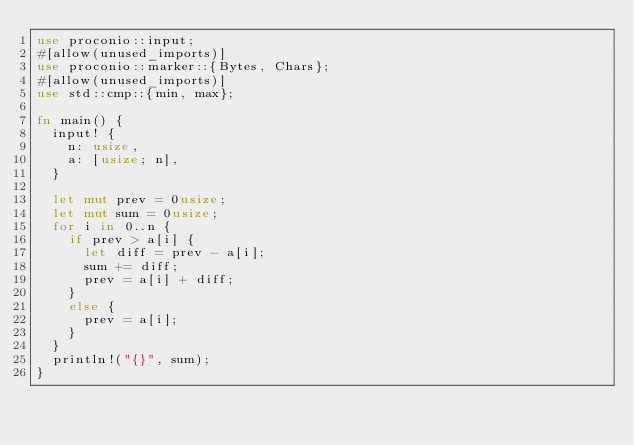Convert code to text. <code><loc_0><loc_0><loc_500><loc_500><_Rust_>use proconio::input;
#[allow(unused_imports)]
use proconio::marker::{Bytes, Chars};
#[allow(unused_imports)]
use std::cmp::{min, max};

fn main() {
	input! {
		n: usize,
		a: [usize; n],
	}

	let mut prev = 0usize;
	let mut sum = 0usize;
	for i in 0..n {
		if prev > a[i] {
			let diff = prev - a[i];
			sum += diff;
			prev = a[i] + diff;
		}
		else {
			prev = a[i];
		}
	}
	println!("{}", sum);
}

</code> 